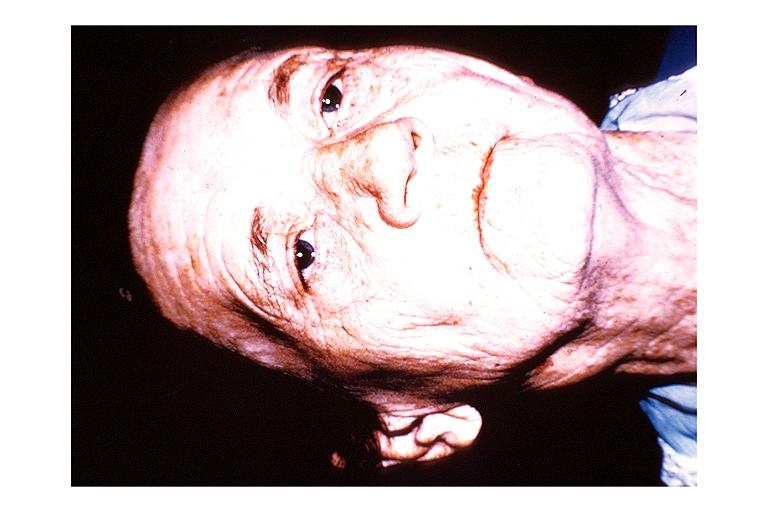s oral present?
Answer the question using a single word or phrase. Yes 